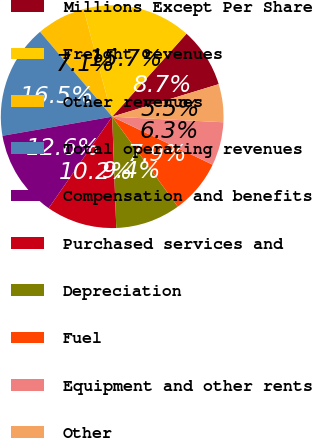Convert chart to OTSL. <chart><loc_0><loc_0><loc_500><loc_500><pie_chart><fcel>Millions Except Per Share<fcel>Freight revenues<fcel>Other revenues<fcel>Total operating revenues<fcel>Compensation and benefits<fcel>Purchased services and<fcel>Depreciation<fcel>Fuel<fcel>Equipment and other rents<fcel>Other<nl><fcel>8.66%<fcel>15.75%<fcel>7.09%<fcel>16.53%<fcel>12.6%<fcel>10.24%<fcel>9.45%<fcel>7.87%<fcel>6.3%<fcel>5.51%<nl></chart> 